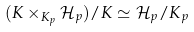<formula> <loc_0><loc_0><loc_500><loc_500>( K \times _ { K _ { p } } \mathcal { H } _ { p } ) / K \simeq \mathcal { H } _ { p } / K _ { p }</formula> 